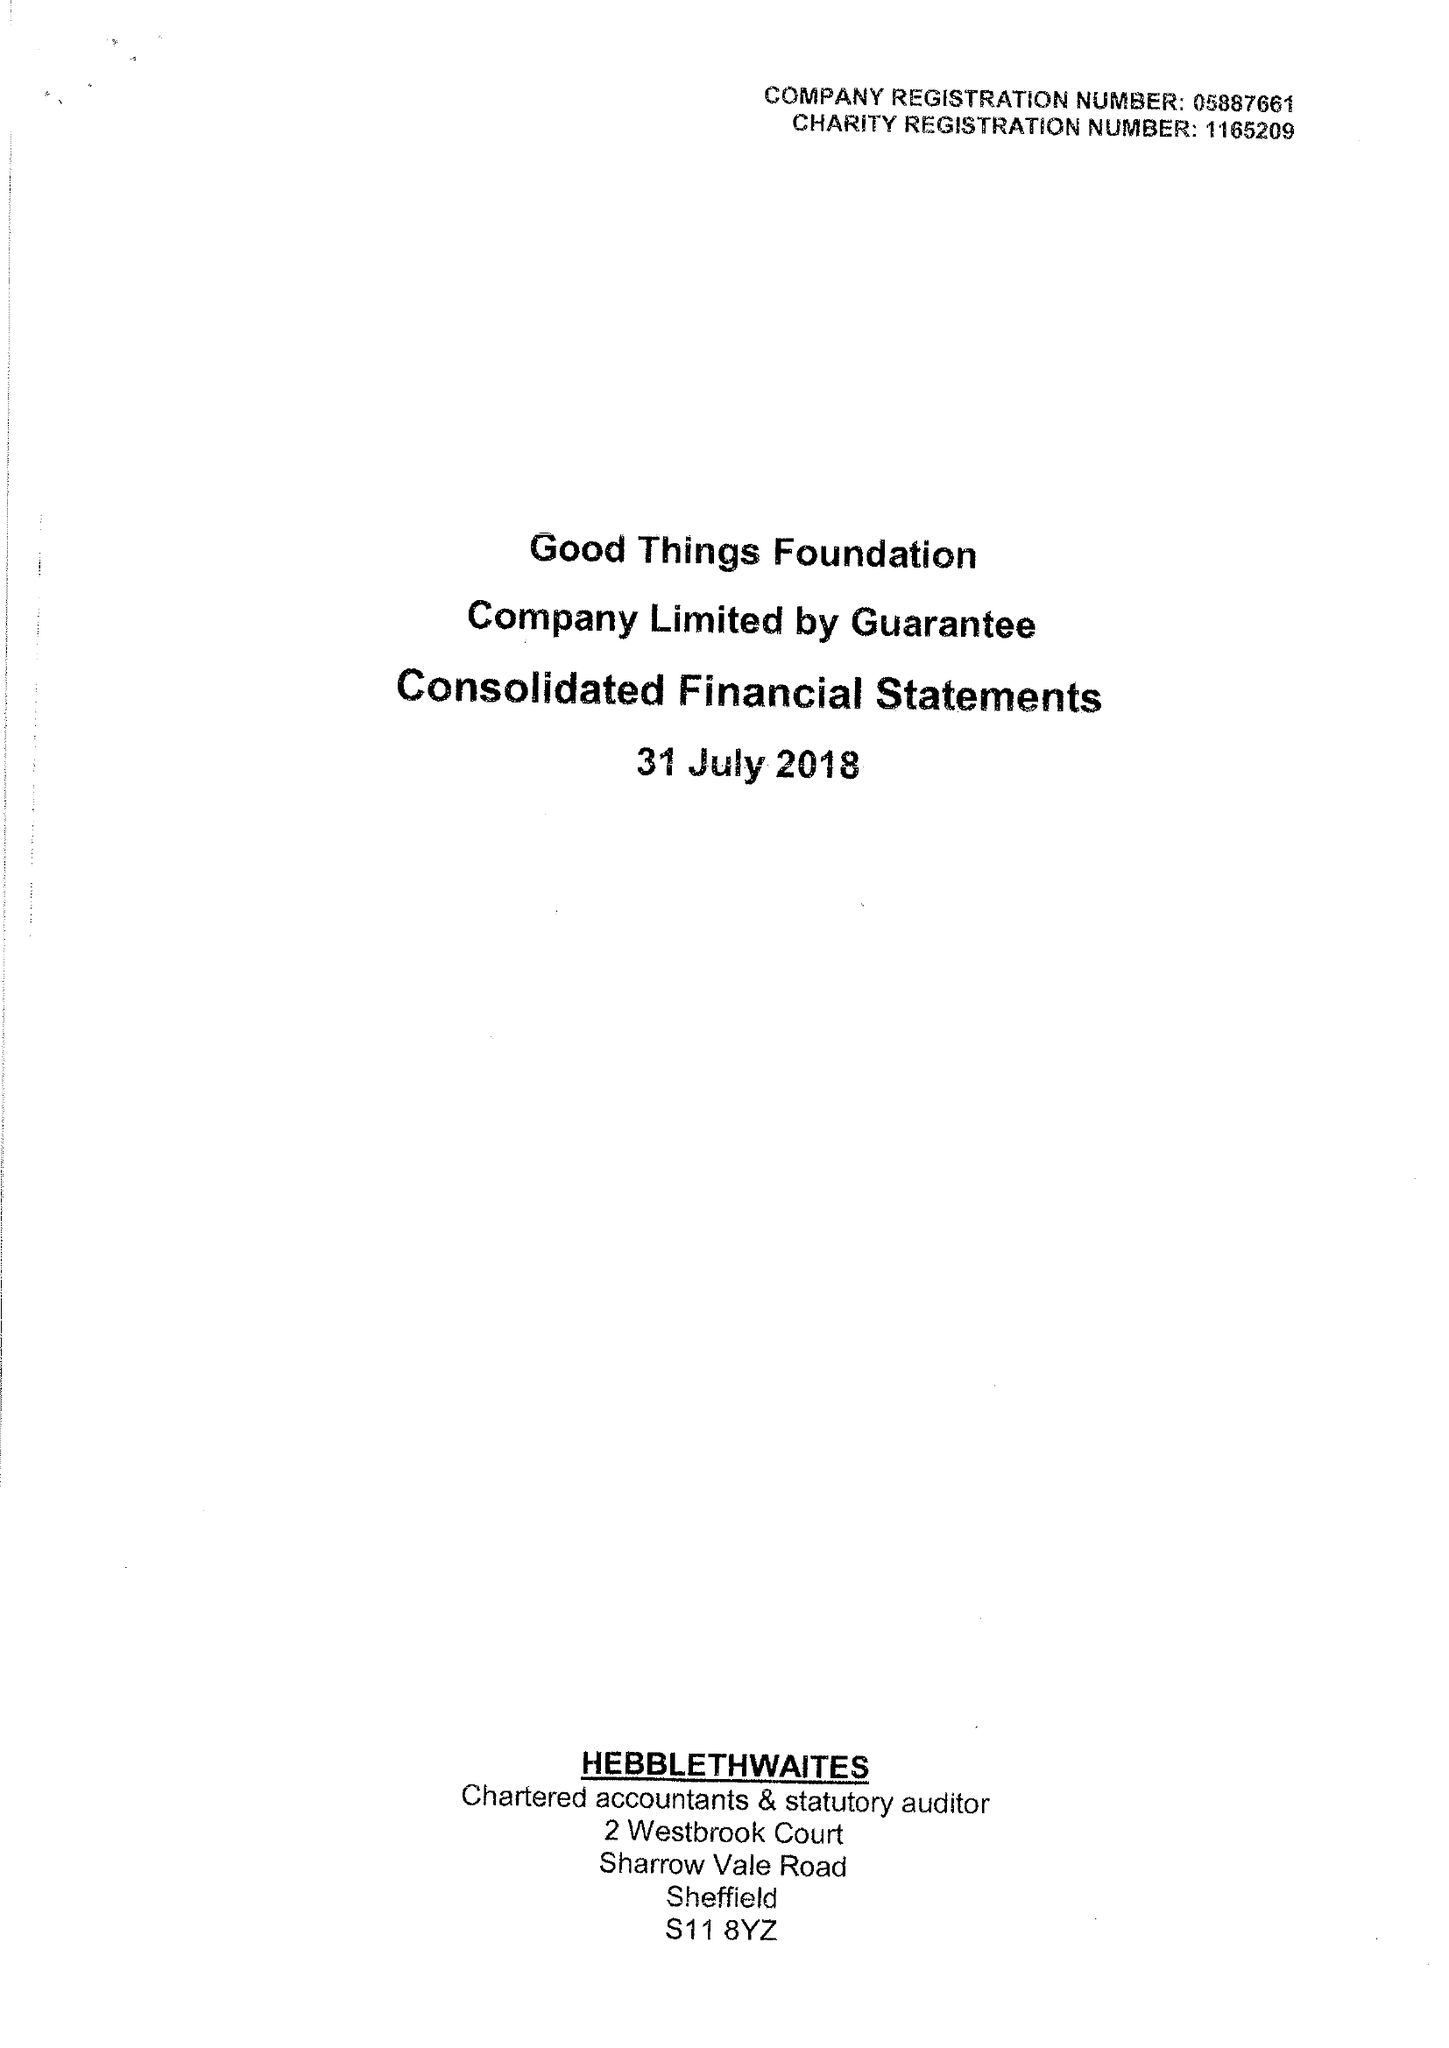What is the value for the charity_number?
Answer the question using a single word or phrase. 1165209 